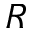Convert formula to latex. <formula><loc_0><loc_0><loc_500><loc_500>R</formula> 